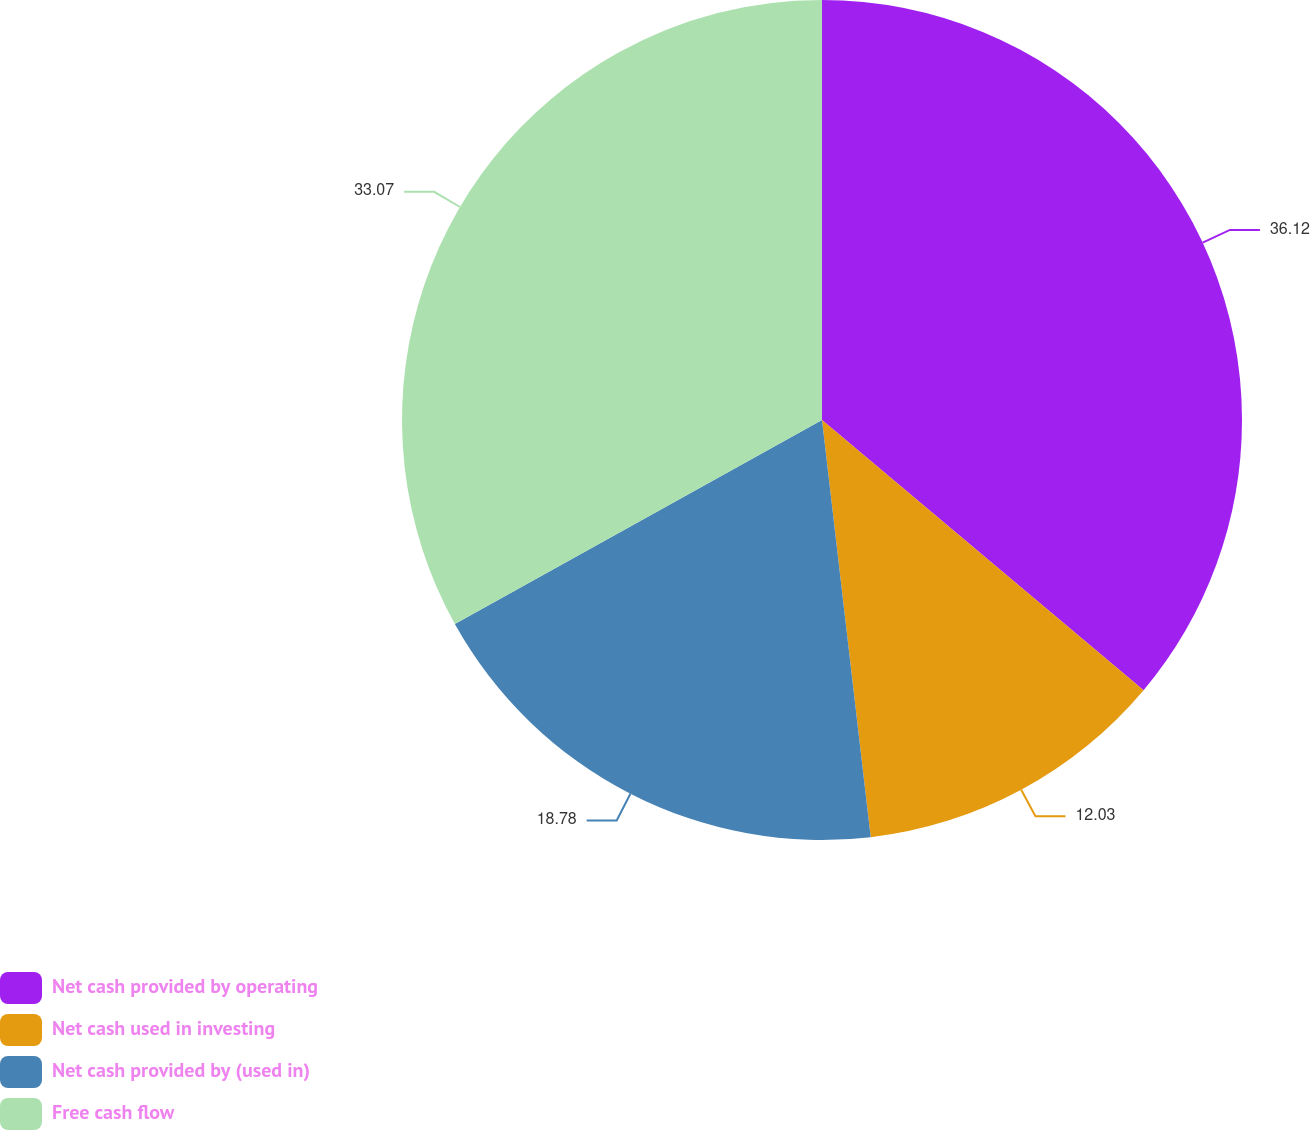<chart> <loc_0><loc_0><loc_500><loc_500><pie_chart><fcel>Net cash provided by operating<fcel>Net cash used in investing<fcel>Net cash provided by (used in)<fcel>Free cash flow<nl><fcel>36.12%<fcel>12.03%<fcel>18.78%<fcel>33.07%<nl></chart> 